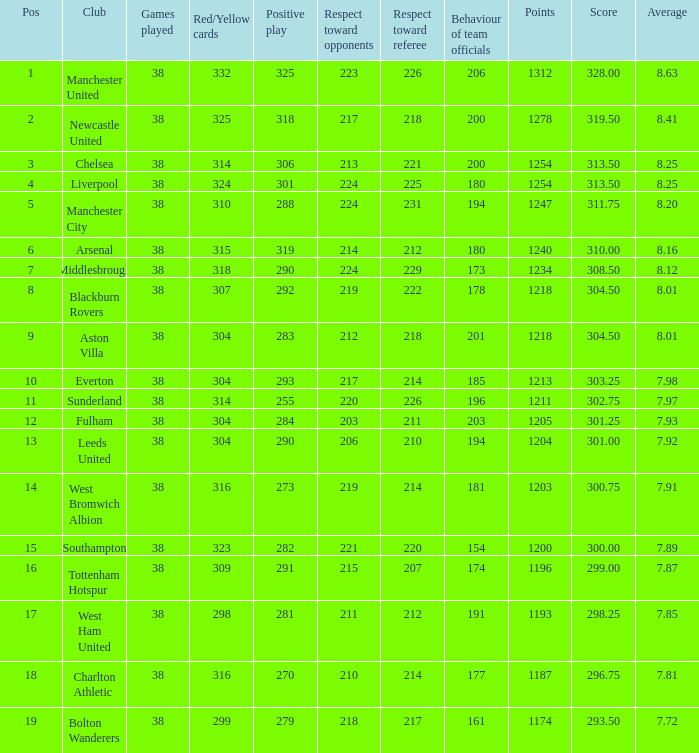What are the aspects of showing 212 respect towards opponents? 1218.0. 